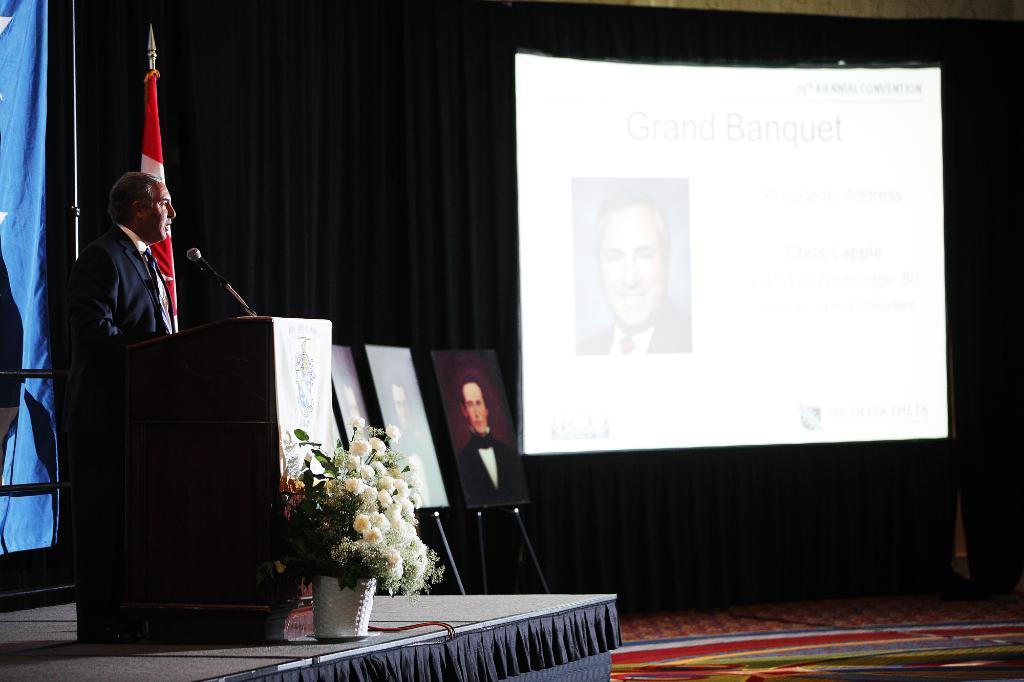Can you describe this image briefly? In this image there is one person standing at left side of this image is wearing blazer and there is a flag behind to him, and there is a curtain at left side of this image which is in blue color and there is a flower pot at bottom of this image and there are some paintings as we can see in this image in middle, and there is a screen at right side of this image and there is a curtain in the background and there is a stage at left side of this image and there is a Mic at top left side of this image. 